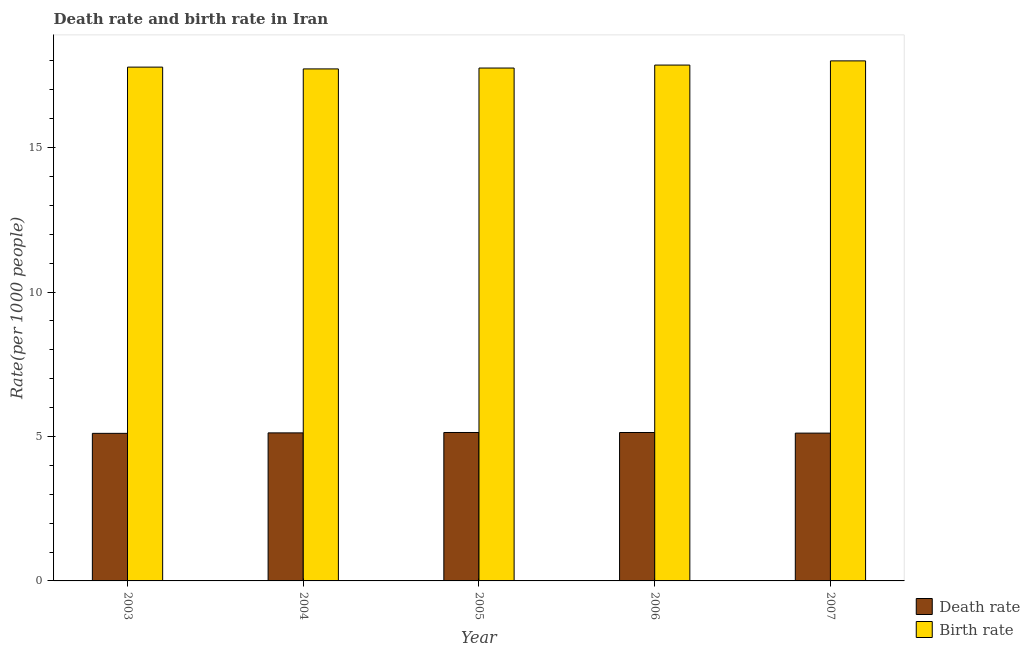Are the number of bars per tick equal to the number of legend labels?
Give a very brief answer. Yes. Are the number of bars on each tick of the X-axis equal?
Give a very brief answer. Yes. How many bars are there on the 5th tick from the left?
Offer a very short reply. 2. What is the label of the 2nd group of bars from the left?
Provide a short and direct response. 2004. In how many cases, is the number of bars for a given year not equal to the number of legend labels?
Your response must be concise. 0. What is the birth rate in 2007?
Ensure brevity in your answer.  18. Across all years, what is the maximum birth rate?
Give a very brief answer. 18. Across all years, what is the minimum death rate?
Your response must be concise. 5.11. In which year was the death rate minimum?
Your answer should be very brief. 2003. What is the total birth rate in the graph?
Provide a succinct answer. 89.12. What is the difference between the birth rate in 2005 and that in 2007?
Provide a succinct answer. -0.25. What is the difference between the death rate in 2003 and the birth rate in 2004?
Your answer should be very brief. -0.02. What is the average death rate per year?
Keep it short and to the point. 5.12. In how many years, is the birth rate greater than 12?
Keep it short and to the point. 5. What is the ratio of the death rate in 2003 to that in 2005?
Your answer should be compact. 0.99. Is the birth rate in 2006 less than that in 2007?
Offer a terse response. Yes. What is the difference between the highest and the second highest death rate?
Ensure brevity in your answer.  0. What is the difference between the highest and the lowest death rate?
Give a very brief answer. 0.03. What does the 2nd bar from the left in 2005 represents?
Keep it short and to the point. Birth rate. What does the 2nd bar from the right in 2003 represents?
Your response must be concise. Death rate. How many bars are there?
Your answer should be very brief. 10. Are all the bars in the graph horizontal?
Your response must be concise. No. How many years are there in the graph?
Provide a succinct answer. 5. Does the graph contain any zero values?
Provide a succinct answer. No. How many legend labels are there?
Make the answer very short. 2. How are the legend labels stacked?
Provide a short and direct response. Vertical. What is the title of the graph?
Your response must be concise. Death rate and birth rate in Iran. Does "Official creditors" appear as one of the legend labels in the graph?
Give a very brief answer. No. What is the label or title of the X-axis?
Provide a short and direct response. Year. What is the label or title of the Y-axis?
Keep it short and to the point. Rate(per 1000 people). What is the Rate(per 1000 people) in Death rate in 2003?
Offer a very short reply. 5.11. What is the Rate(per 1000 people) of Birth rate in 2003?
Ensure brevity in your answer.  17.79. What is the Rate(per 1000 people) in Death rate in 2004?
Make the answer very short. 5.12. What is the Rate(per 1000 people) in Birth rate in 2004?
Provide a short and direct response. 17.72. What is the Rate(per 1000 people) of Death rate in 2005?
Keep it short and to the point. 5.14. What is the Rate(per 1000 people) of Birth rate in 2005?
Ensure brevity in your answer.  17.75. What is the Rate(per 1000 people) in Death rate in 2006?
Keep it short and to the point. 5.14. What is the Rate(per 1000 people) in Birth rate in 2006?
Ensure brevity in your answer.  17.86. What is the Rate(per 1000 people) of Death rate in 2007?
Your answer should be very brief. 5.12. What is the Rate(per 1000 people) in Birth rate in 2007?
Ensure brevity in your answer.  18. Across all years, what is the maximum Rate(per 1000 people) in Death rate?
Your answer should be compact. 5.14. Across all years, what is the maximum Rate(per 1000 people) in Birth rate?
Offer a very short reply. 18. Across all years, what is the minimum Rate(per 1000 people) in Death rate?
Your answer should be very brief. 5.11. Across all years, what is the minimum Rate(per 1000 people) in Birth rate?
Your answer should be very brief. 17.72. What is the total Rate(per 1000 people) in Death rate in the graph?
Your answer should be compact. 25.62. What is the total Rate(per 1000 people) in Birth rate in the graph?
Provide a succinct answer. 89.12. What is the difference between the Rate(per 1000 people) of Death rate in 2003 and that in 2004?
Give a very brief answer. -0.02. What is the difference between the Rate(per 1000 people) of Birth rate in 2003 and that in 2004?
Your response must be concise. 0.06. What is the difference between the Rate(per 1000 people) of Death rate in 2003 and that in 2005?
Give a very brief answer. -0.03. What is the difference between the Rate(per 1000 people) in Birth rate in 2003 and that in 2005?
Offer a very short reply. 0.03. What is the difference between the Rate(per 1000 people) in Death rate in 2003 and that in 2006?
Offer a terse response. -0.03. What is the difference between the Rate(per 1000 people) of Birth rate in 2003 and that in 2006?
Provide a short and direct response. -0.07. What is the difference between the Rate(per 1000 people) in Death rate in 2003 and that in 2007?
Keep it short and to the point. -0.01. What is the difference between the Rate(per 1000 people) of Birth rate in 2003 and that in 2007?
Your response must be concise. -0.22. What is the difference between the Rate(per 1000 people) of Death rate in 2004 and that in 2005?
Give a very brief answer. -0.01. What is the difference between the Rate(per 1000 people) of Birth rate in 2004 and that in 2005?
Make the answer very short. -0.03. What is the difference between the Rate(per 1000 people) in Death rate in 2004 and that in 2006?
Your answer should be compact. -0.01. What is the difference between the Rate(per 1000 people) in Birth rate in 2004 and that in 2006?
Your answer should be compact. -0.13. What is the difference between the Rate(per 1000 people) in Death rate in 2004 and that in 2007?
Offer a very short reply. 0.01. What is the difference between the Rate(per 1000 people) of Birth rate in 2004 and that in 2007?
Your answer should be compact. -0.28. What is the difference between the Rate(per 1000 people) of Death rate in 2005 and that in 2006?
Your response must be concise. 0. What is the difference between the Rate(per 1000 people) of Birth rate in 2005 and that in 2006?
Make the answer very short. -0.1. What is the difference between the Rate(per 1000 people) of Death rate in 2005 and that in 2007?
Provide a succinct answer. 0.02. What is the difference between the Rate(per 1000 people) in Birth rate in 2005 and that in 2007?
Your answer should be very brief. -0.25. What is the difference between the Rate(per 1000 people) in Death rate in 2006 and that in 2007?
Make the answer very short. 0.02. What is the difference between the Rate(per 1000 people) in Birth rate in 2006 and that in 2007?
Give a very brief answer. -0.14. What is the difference between the Rate(per 1000 people) in Death rate in 2003 and the Rate(per 1000 people) in Birth rate in 2004?
Your response must be concise. -12.62. What is the difference between the Rate(per 1000 people) in Death rate in 2003 and the Rate(per 1000 people) in Birth rate in 2005?
Keep it short and to the point. -12.64. What is the difference between the Rate(per 1000 people) in Death rate in 2003 and the Rate(per 1000 people) in Birth rate in 2006?
Keep it short and to the point. -12.75. What is the difference between the Rate(per 1000 people) of Death rate in 2003 and the Rate(per 1000 people) of Birth rate in 2007?
Your answer should be very brief. -12.89. What is the difference between the Rate(per 1000 people) of Death rate in 2004 and the Rate(per 1000 people) of Birth rate in 2005?
Make the answer very short. -12.63. What is the difference between the Rate(per 1000 people) in Death rate in 2004 and the Rate(per 1000 people) in Birth rate in 2006?
Provide a short and direct response. -12.73. What is the difference between the Rate(per 1000 people) in Death rate in 2004 and the Rate(per 1000 people) in Birth rate in 2007?
Your answer should be compact. -12.88. What is the difference between the Rate(per 1000 people) of Death rate in 2005 and the Rate(per 1000 people) of Birth rate in 2006?
Give a very brief answer. -12.72. What is the difference between the Rate(per 1000 people) of Death rate in 2005 and the Rate(per 1000 people) of Birth rate in 2007?
Your response must be concise. -12.86. What is the difference between the Rate(per 1000 people) of Death rate in 2006 and the Rate(per 1000 people) of Birth rate in 2007?
Your response must be concise. -12.86. What is the average Rate(per 1000 people) of Death rate per year?
Provide a short and direct response. 5.12. What is the average Rate(per 1000 people) in Birth rate per year?
Ensure brevity in your answer.  17.82. In the year 2003, what is the difference between the Rate(per 1000 people) in Death rate and Rate(per 1000 people) in Birth rate?
Offer a very short reply. -12.68. In the year 2004, what is the difference between the Rate(per 1000 people) in Death rate and Rate(per 1000 people) in Birth rate?
Give a very brief answer. -12.6. In the year 2005, what is the difference between the Rate(per 1000 people) in Death rate and Rate(per 1000 people) in Birth rate?
Make the answer very short. -12.62. In the year 2006, what is the difference between the Rate(per 1000 people) in Death rate and Rate(per 1000 people) in Birth rate?
Your answer should be very brief. -12.72. In the year 2007, what is the difference between the Rate(per 1000 people) of Death rate and Rate(per 1000 people) of Birth rate?
Keep it short and to the point. -12.88. What is the ratio of the Rate(per 1000 people) in Death rate in 2003 to that in 2004?
Your answer should be compact. 1. What is the ratio of the Rate(per 1000 people) of Death rate in 2003 to that in 2005?
Your response must be concise. 0.99. What is the ratio of the Rate(per 1000 people) of Death rate in 2003 to that in 2006?
Offer a terse response. 0.99. What is the ratio of the Rate(per 1000 people) of Birth rate in 2003 to that in 2006?
Make the answer very short. 1. What is the ratio of the Rate(per 1000 people) in Death rate in 2003 to that in 2007?
Your response must be concise. 1. What is the ratio of the Rate(per 1000 people) in Death rate in 2004 to that in 2005?
Your response must be concise. 1. What is the ratio of the Rate(per 1000 people) of Birth rate in 2004 to that in 2005?
Offer a very short reply. 1. What is the ratio of the Rate(per 1000 people) of Birth rate in 2004 to that in 2006?
Your answer should be very brief. 0.99. What is the ratio of the Rate(per 1000 people) of Death rate in 2004 to that in 2007?
Your answer should be compact. 1. What is the ratio of the Rate(per 1000 people) in Birth rate in 2004 to that in 2007?
Your answer should be compact. 0.98. What is the ratio of the Rate(per 1000 people) in Death rate in 2005 to that in 2006?
Offer a very short reply. 1. What is the ratio of the Rate(per 1000 people) of Death rate in 2005 to that in 2007?
Offer a terse response. 1. What is the ratio of the Rate(per 1000 people) of Birth rate in 2005 to that in 2007?
Offer a terse response. 0.99. What is the difference between the highest and the second highest Rate(per 1000 people) of Death rate?
Provide a short and direct response. 0. What is the difference between the highest and the second highest Rate(per 1000 people) in Birth rate?
Provide a short and direct response. 0.14. What is the difference between the highest and the lowest Rate(per 1000 people) of Death rate?
Your answer should be compact. 0.03. What is the difference between the highest and the lowest Rate(per 1000 people) of Birth rate?
Offer a terse response. 0.28. 